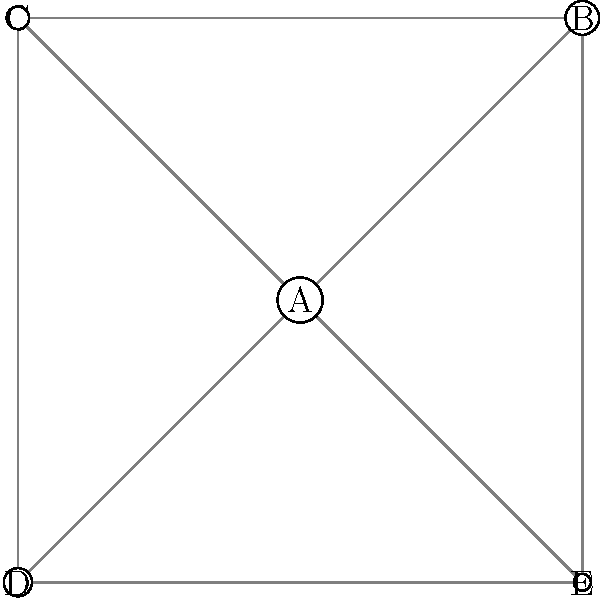In the protein-protein interaction network shown, which protein has the strongest direct interaction with protein A, and what visualization technique is used to represent interaction strength? To answer this question, we need to analyze the protein-protein interaction network visualization:

1. The network is represented as a graph, where nodes (circles) represent proteins and edges (lines) represent interactions between proteins.

2. The interaction strength is visually encoded by the size of the nodes. Larger nodes indicate stronger interactions with protein A, which is at the center of the network.

3. We can observe five proteins in the network: A, B, C, D, and E.

4. By comparing the sizes of the nodes connected to protein A:
   - B (top right) has the largest node size
   - E (bottom right) has the second-largest node size
   - C (top left) has the third-largest node size
   - D (bottom left) has the smallest node size

5. Since B has the largest node size among proteins directly connected to A, it represents the strongest interaction with protein A.

6. The visualization technique used to represent interaction strength is varying the size of the nodes. This technique is called "node size encoding" or "size-based node weighting."
Answer: Protein B; node size encoding 